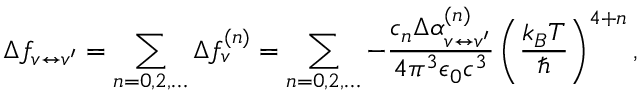Convert formula to latex. <formula><loc_0><loc_0><loc_500><loc_500>\Delta f _ { v \leftrightarrow v ^ { \prime } } = \sum _ { n = 0 , 2 , \dots } \Delta f _ { v } ^ { ( n ) } = \sum _ { n = 0 , 2 , \dots } - \frac { c _ { n } \Delta \alpha _ { v \leftrightarrow v ^ { \prime } } ^ { ( n ) } } { 4 \pi ^ { 3 } \epsilon _ { 0 } c ^ { 3 } } \left ( \frac { k _ { B } T } { } \right ) ^ { 4 + n } ,</formula> 